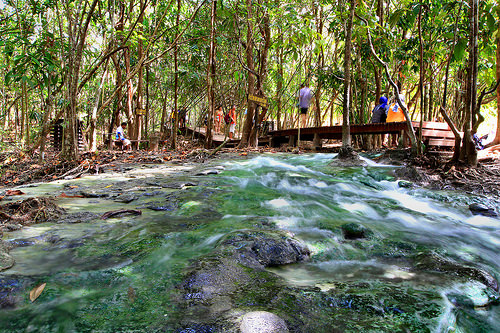<image>
Is there a man on the bridge? Yes. Looking at the image, I can see the man is positioned on top of the bridge, with the bridge providing support. Is there a tree to the right of the water? No. The tree is not to the right of the water. The horizontal positioning shows a different relationship. 